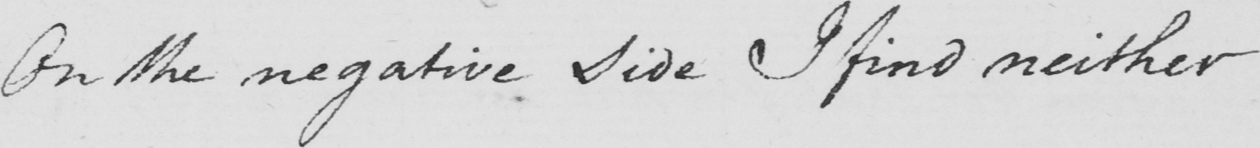What is written in this line of handwriting? On the negative side I find neither 